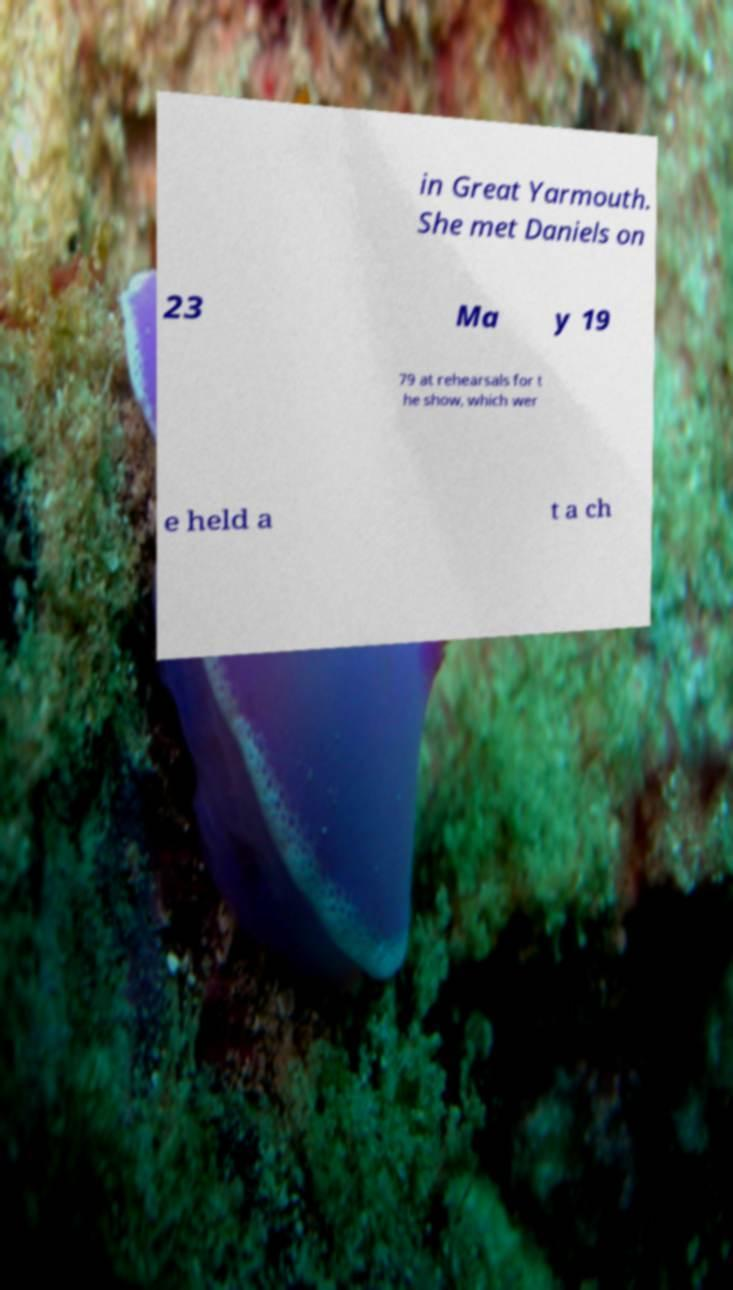Can you read and provide the text displayed in the image?This photo seems to have some interesting text. Can you extract and type it out for me? in Great Yarmouth. She met Daniels on 23 Ma y 19 79 at rehearsals for t he show, which wer e held a t a ch 